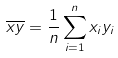<formula> <loc_0><loc_0><loc_500><loc_500>\overline { x y } = \frac { 1 } { n } \sum _ { i = 1 } ^ { n } x _ { i } y _ { i }</formula> 